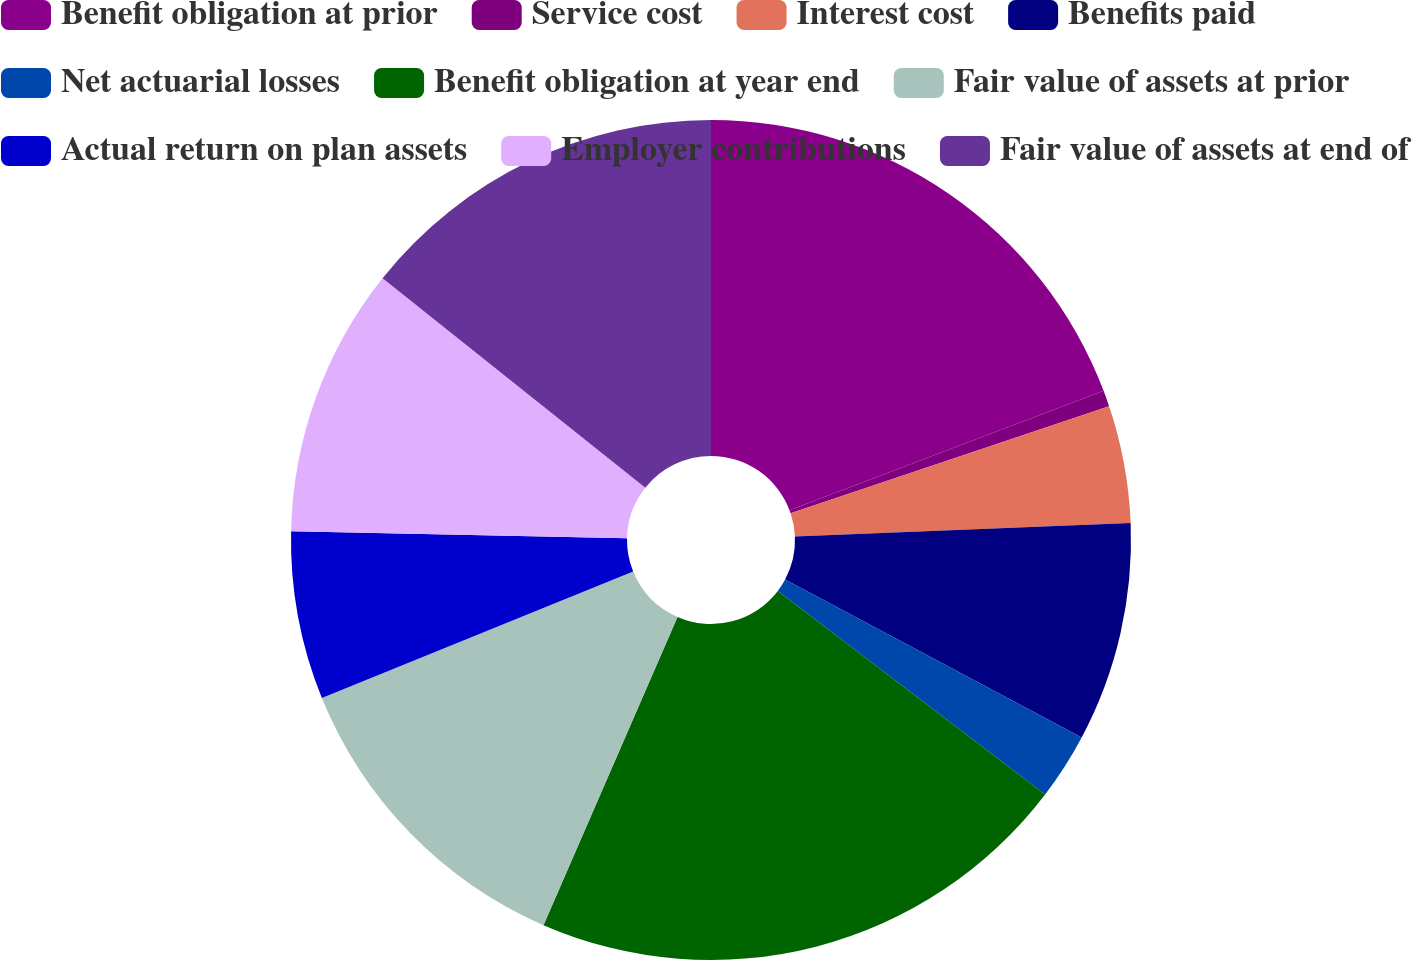Convert chart to OTSL. <chart><loc_0><loc_0><loc_500><loc_500><pie_chart><fcel>Benefit obligation at prior<fcel>Service cost<fcel>Interest cost<fcel>Benefits paid<fcel>Net actuarial losses<fcel>Benefit obligation at year end<fcel>Fair value of assets at prior<fcel>Actual return on plan assets<fcel>Employer contributions<fcel>Fair value of assets at end of<nl><fcel>19.22%<fcel>0.62%<fcel>4.52%<fcel>8.43%<fcel>2.57%<fcel>21.17%<fcel>12.33%<fcel>6.47%<fcel>10.38%<fcel>14.29%<nl></chart> 